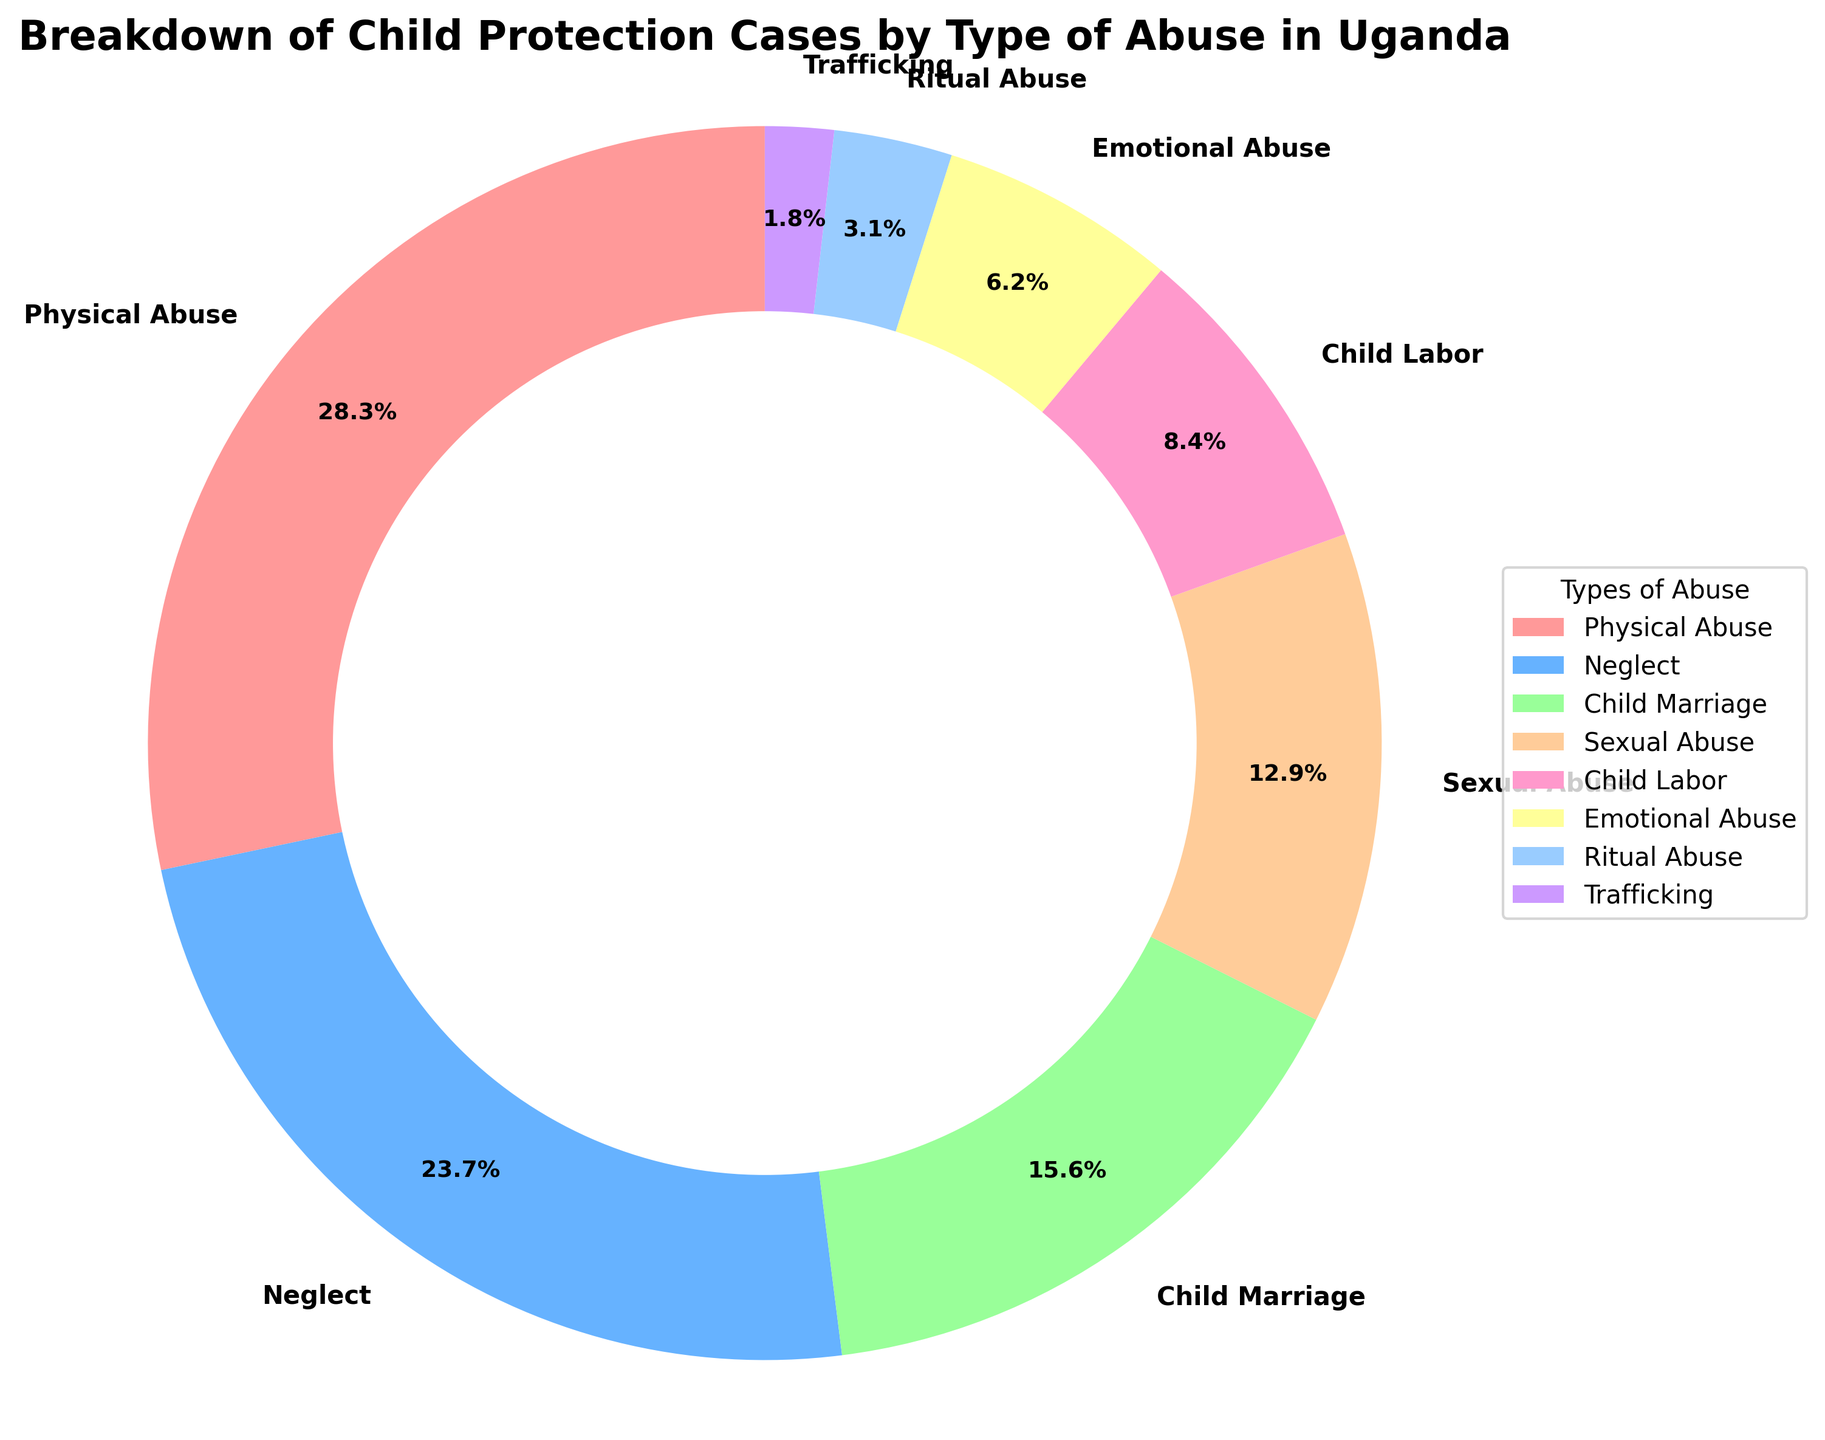What's the combined percentage of cases due to Emotional Abuse and Ritual Abuse? In the chart, Emotional Abuse accounts for 6.2%, and Ritual Abuse accounts for 3.1%. By adding these together, 6.2% + 3.1% = 9.3%.
Answer: 9.3% Which type of abuse is shown in the largest segment of the pie chart? The largest segment is labeled "Physical Abuse," which accounts for 28.3% of the cases. This is the highest percentage among all the types listed.
Answer: Physical Abuse Is there a type of abuse that has a percentage smaller than Child Labor but larger than Sexual Abuse? The chart shows Child Labor at 8.4% and Sexual Abuse at 12.9%. We need to find a type of abuse with a percentage between 8.4% and 12.9%. The only type that fits this criterion is Emotional Abuse with 6.2%, which does not meet our requirement. So, there is no such type.
Answer: No What proportion of cases are attributed to Child Marriage and Sexual Abuse combined? Child Marriage accounts for 15.6% and Sexual Abuse accounts for 12.9%. Adding these percentages together, we get 15.6% + 12.9% = 28.5%.
Answer: 28.5% How does the prevalence of Neglect compare to that of Child Labor? Neglect has a percentage of 23.7%, whereas Child Labor has 8.4%. Neglect is significantly more prevalent than Child Labor.
Answer: More What are the two types of abuse with the smallest percentages? Referring to the pie chart, the smallest segments are for Trafficking at 1.8% and Ritual Abuse at 3.1%.
Answer: Trafficking and Ritual Abuse Which type of abuse is depicted with the sky-blue color in the pie chart? Recalling the color code for the pie chart, the sky-blue segment represents Child Labor, which accounts for 8.4%.
Answer: Child Labor Is Child Marriage more prevalent than Emotional Abuse, but less than Neglect? Child Marriage is at 15.6%, Emotional Abuse is at 6.2%, and Neglect is at 23.7%. Child Marriage is indeed more prevalent than Emotional Abuse and less than Neglect.
Answer: Yes What is the difference in percentage points between Physical Abuse and Sexual Abuse cases? Physical Abuse is 28.3% and Sexual Abuse is 12.9%. Subtracting these values 28.3% - 12.9% = 15.4%, showing the difference in percentage points.
Answer: 15.4% What is the sum of percentages for Physical Abuse, Neglect, and Child Marriage cases? Physical Abuse is 28.3%, Neglect is 23.7%, and Child Marriage is 15.6%. Adding these together, 28.3% + 23.7% + 15.6% = 67.6%.
Answer: 67.6% 